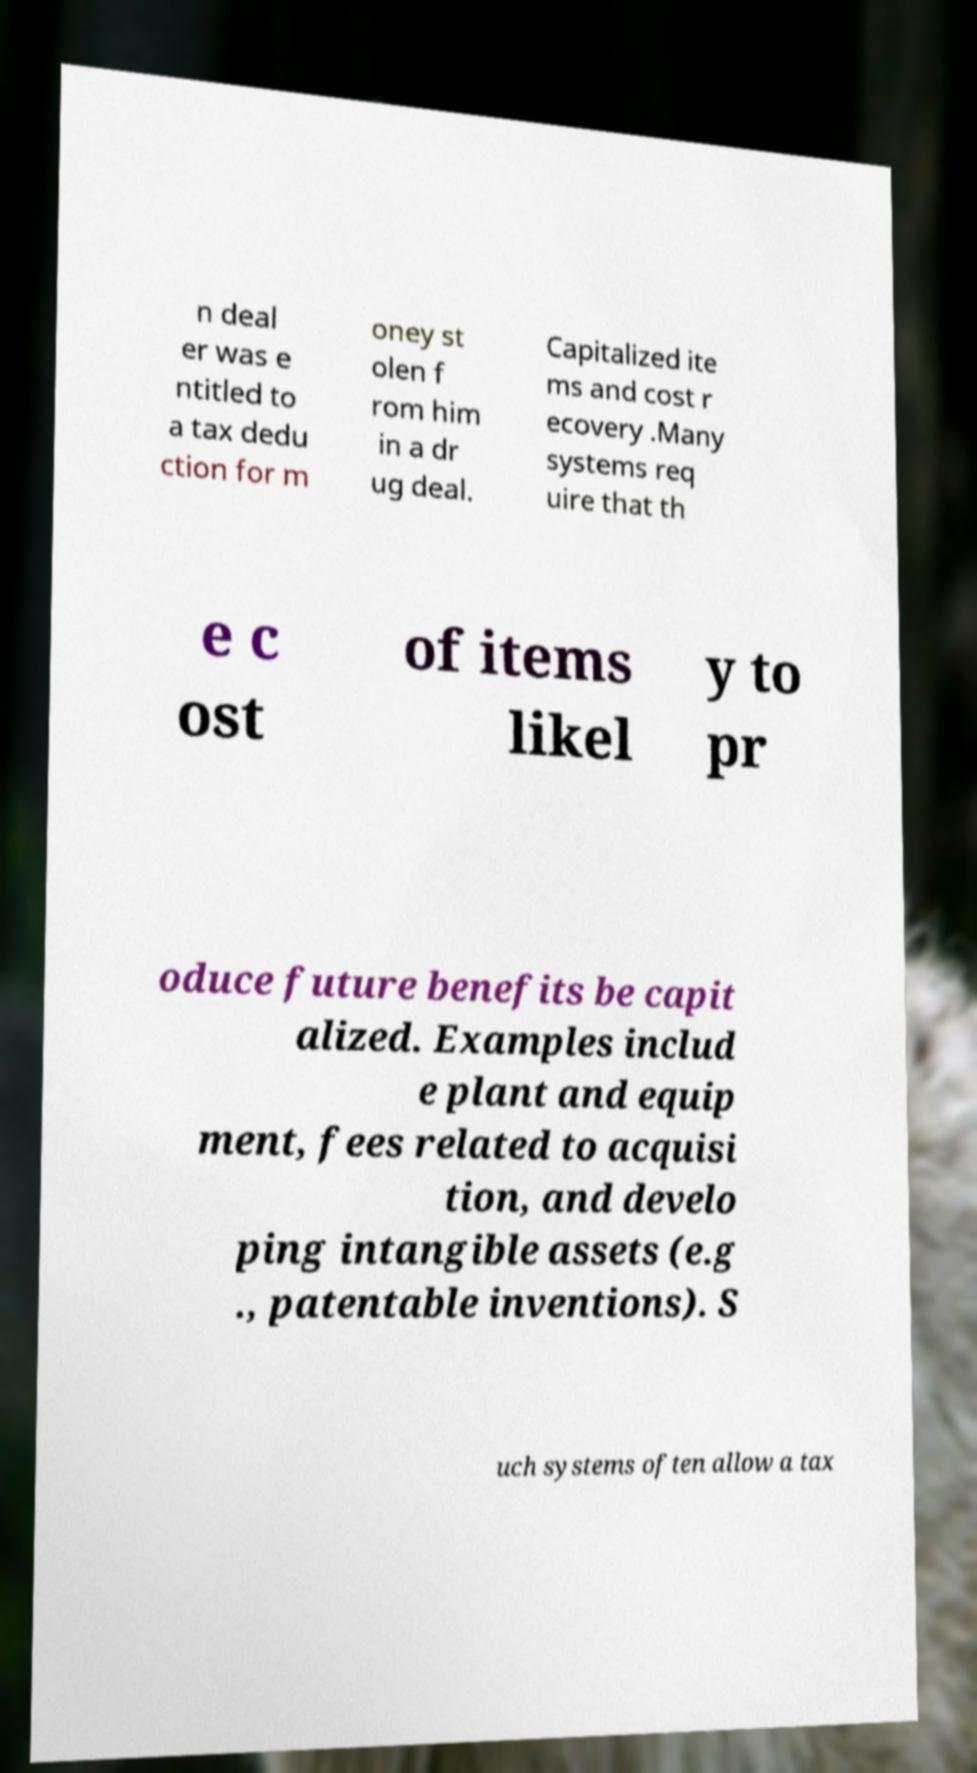What messages or text are displayed in this image? I need them in a readable, typed format. n deal er was e ntitled to a tax dedu ction for m oney st olen f rom him in a dr ug deal. Capitalized ite ms and cost r ecovery .Many systems req uire that th e c ost of items likel y to pr oduce future benefits be capit alized. Examples includ e plant and equip ment, fees related to acquisi tion, and develo ping intangible assets (e.g ., patentable inventions). S uch systems often allow a tax 